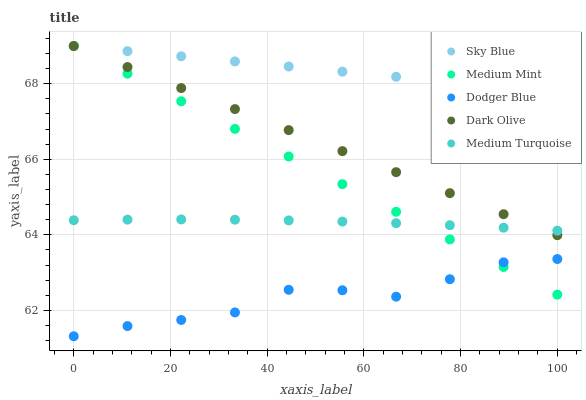Does Dodger Blue have the minimum area under the curve?
Answer yes or no. Yes. Does Sky Blue have the maximum area under the curve?
Answer yes or no. Yes. Does Dark Olive have the minimum area under the curve?
Answer yes or no. No. Does Dark Olive have the maximum area under the curve?
Answer yes or no. No. Is Dark Olive the smoothest?
Answer yes or no. Yes. Is Dodger Blue the roughest?
Answer yes or no. Yes. Is Sky Blue the smoothest?
Answer yes or no. No. Is Sky Blue the roughest?
Answer yes or no. No. Does Dodger Blue have the lowest value?
Answer yes or no. Yes. Does Dark Olive have the lowest value?
Answer yes or no. No. Does Dark Olive have the highest value?
Answer yes or no. Yes. Does Dodger Blue have the highest value?
Answer yes or no. No. Is Dodger Blue less than Dark Olive?
Answer yes or no. Yes. Is Dark Olive greater than Dodger Blue?
Answer yes or no. Yes. Does Dodger Blue intersect Medium Mint?
Answer yes or no. Yes. Is Dodger Blue less than Medium Mint?
Answer yes or no. No. Is Dodger Blue greater than Medium Mint?
Answer yes or no. No. Does Dodger Blue intersect Dark Olive?
Answer yes or no. No. 